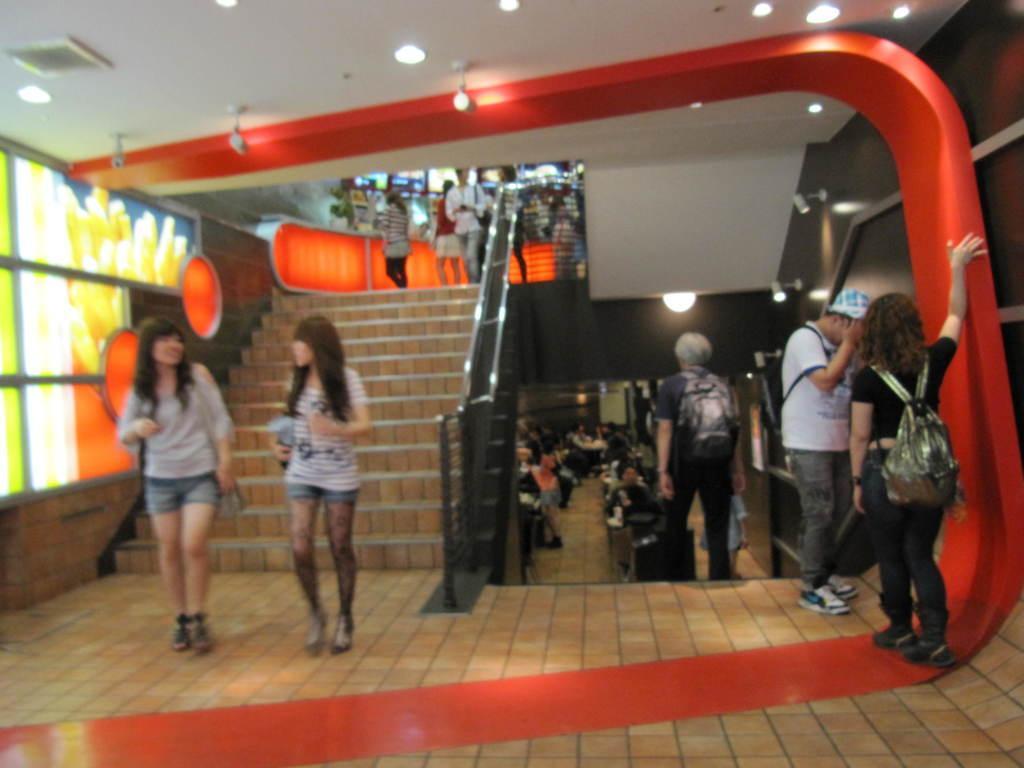In one or two sentences, can you explain what this image depicts? In this picture at the left bottom this look like class and one man standing near the class and there are two other girl who are in the left side. 